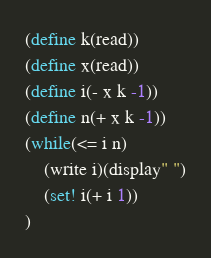Convert code to text. <code><loc_0><loc_0><loc_500><loc_500><_Scheme_>(define k(read))
(define x(read))
(define i(- x k -1))
(define n(+ x k -1))
(while(<= i n)
	(write i)(display" ")
	(set! i(+ i 1))
)</code> 